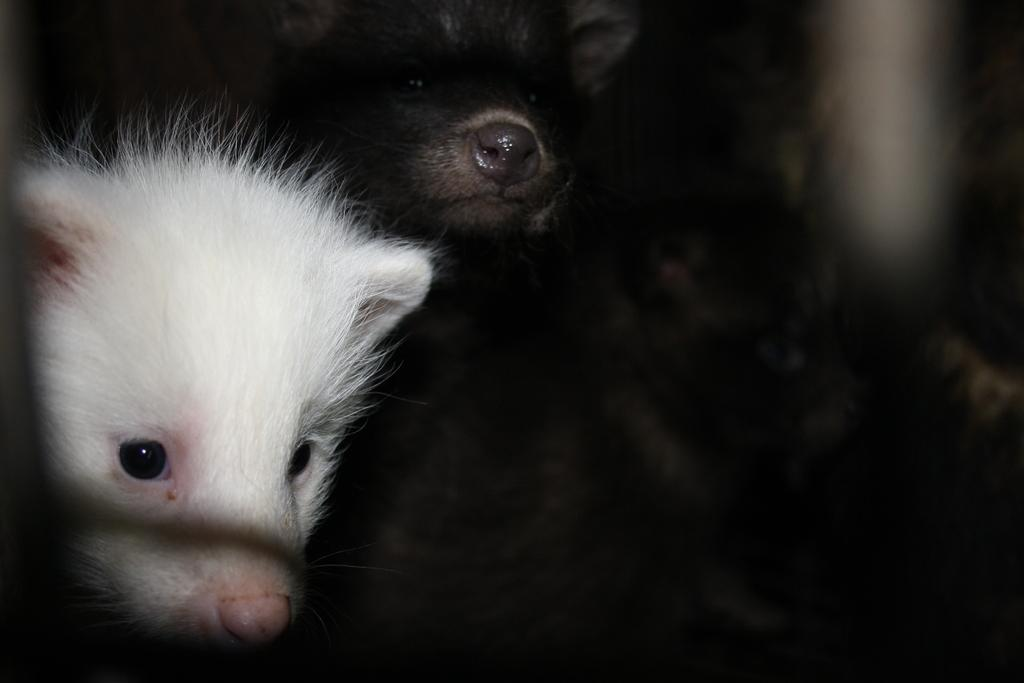What type of living organisms can be seen in the image? There are animals in the image. What colors are the animals in the image? The animals are white and black in color. What can be observed about the background of the image? The background of the image is dark. What type of window can be seen in the image? There is no window present in the image; it features animals with white and black coloring against a dark background. What kind of camping gear is visible in the image? There is no camping gear present in the image; it only contains animals and information about their colors and the background. 